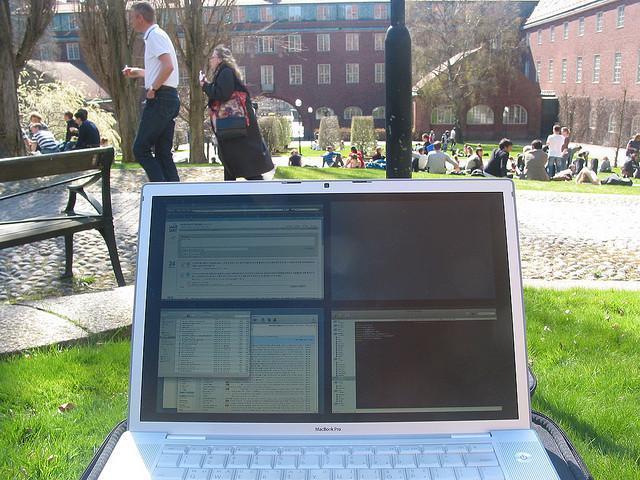How many benches are there?
Give a very brief answer. 1. How many people are in the photo?
Give a very brief answer. 3. How many sheep are sticking their head through the fence?
Give a very brief answer. 0. 